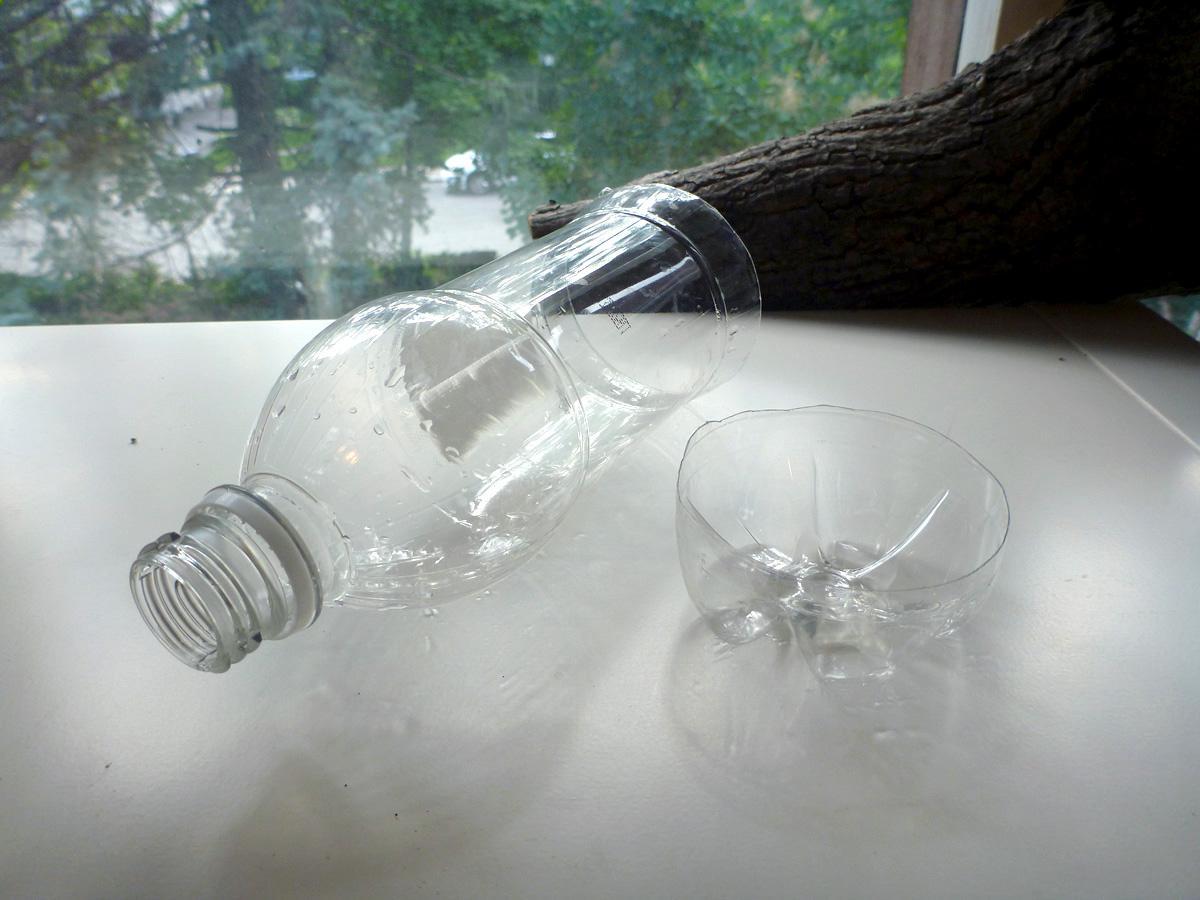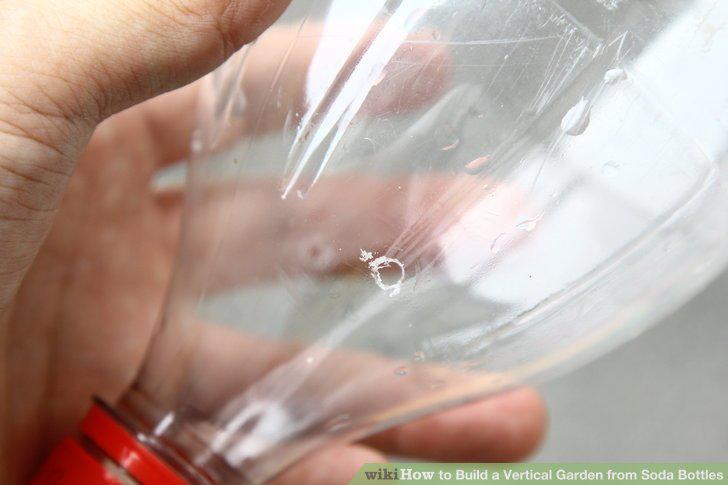The first image is the image on the left, the second image is the image on the right. Given the left and right images, does the statement "The bottles in one of the images are attached to a wall as planters." hold true? Answer yes or no. No. 